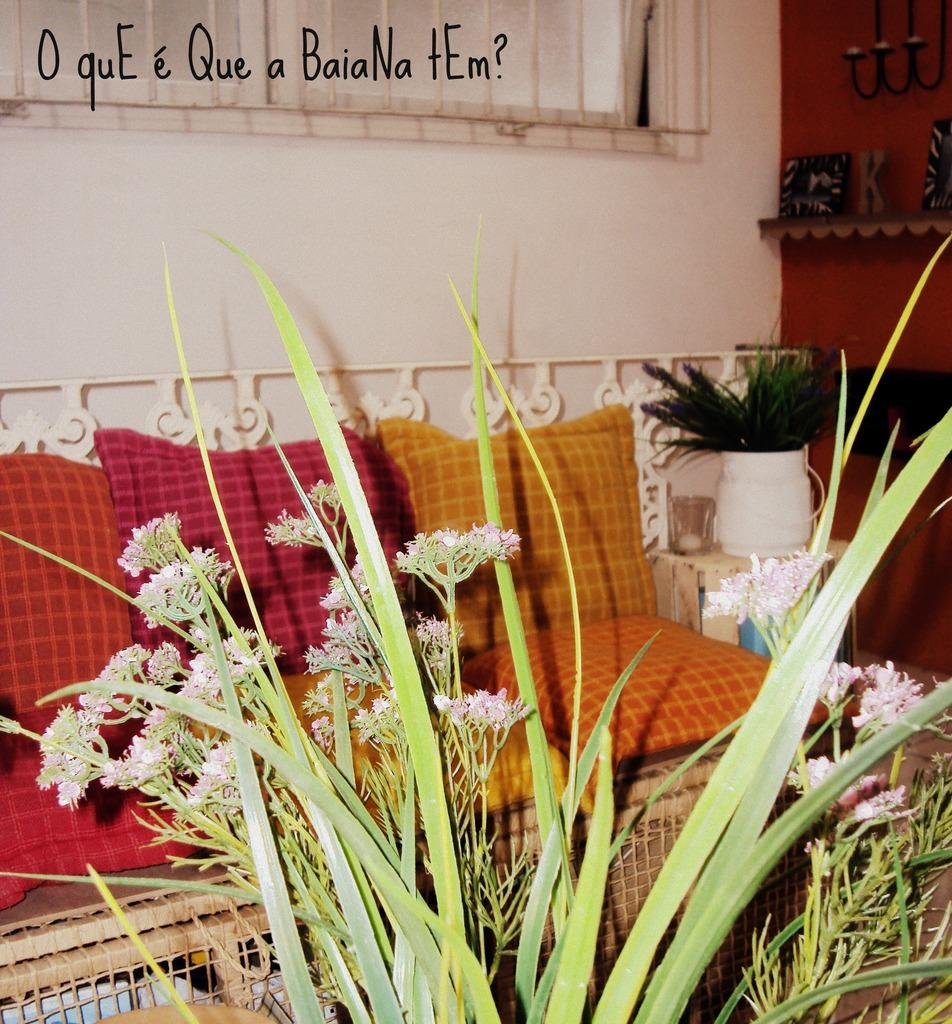What type of plants can be seen in the image? There are flowers in the image. What are the flowers placed in? There are flower vases in the image. What type of furniture is located near the flower vases? A sofa is present beside the flower vase. What material is used to create the rods in the image? Metal rods are visible in the image. What type of pie is being served on the sofa in the image? There is no pie present in the image; it features flowers, flower vases, a sofa, and metal rods. 